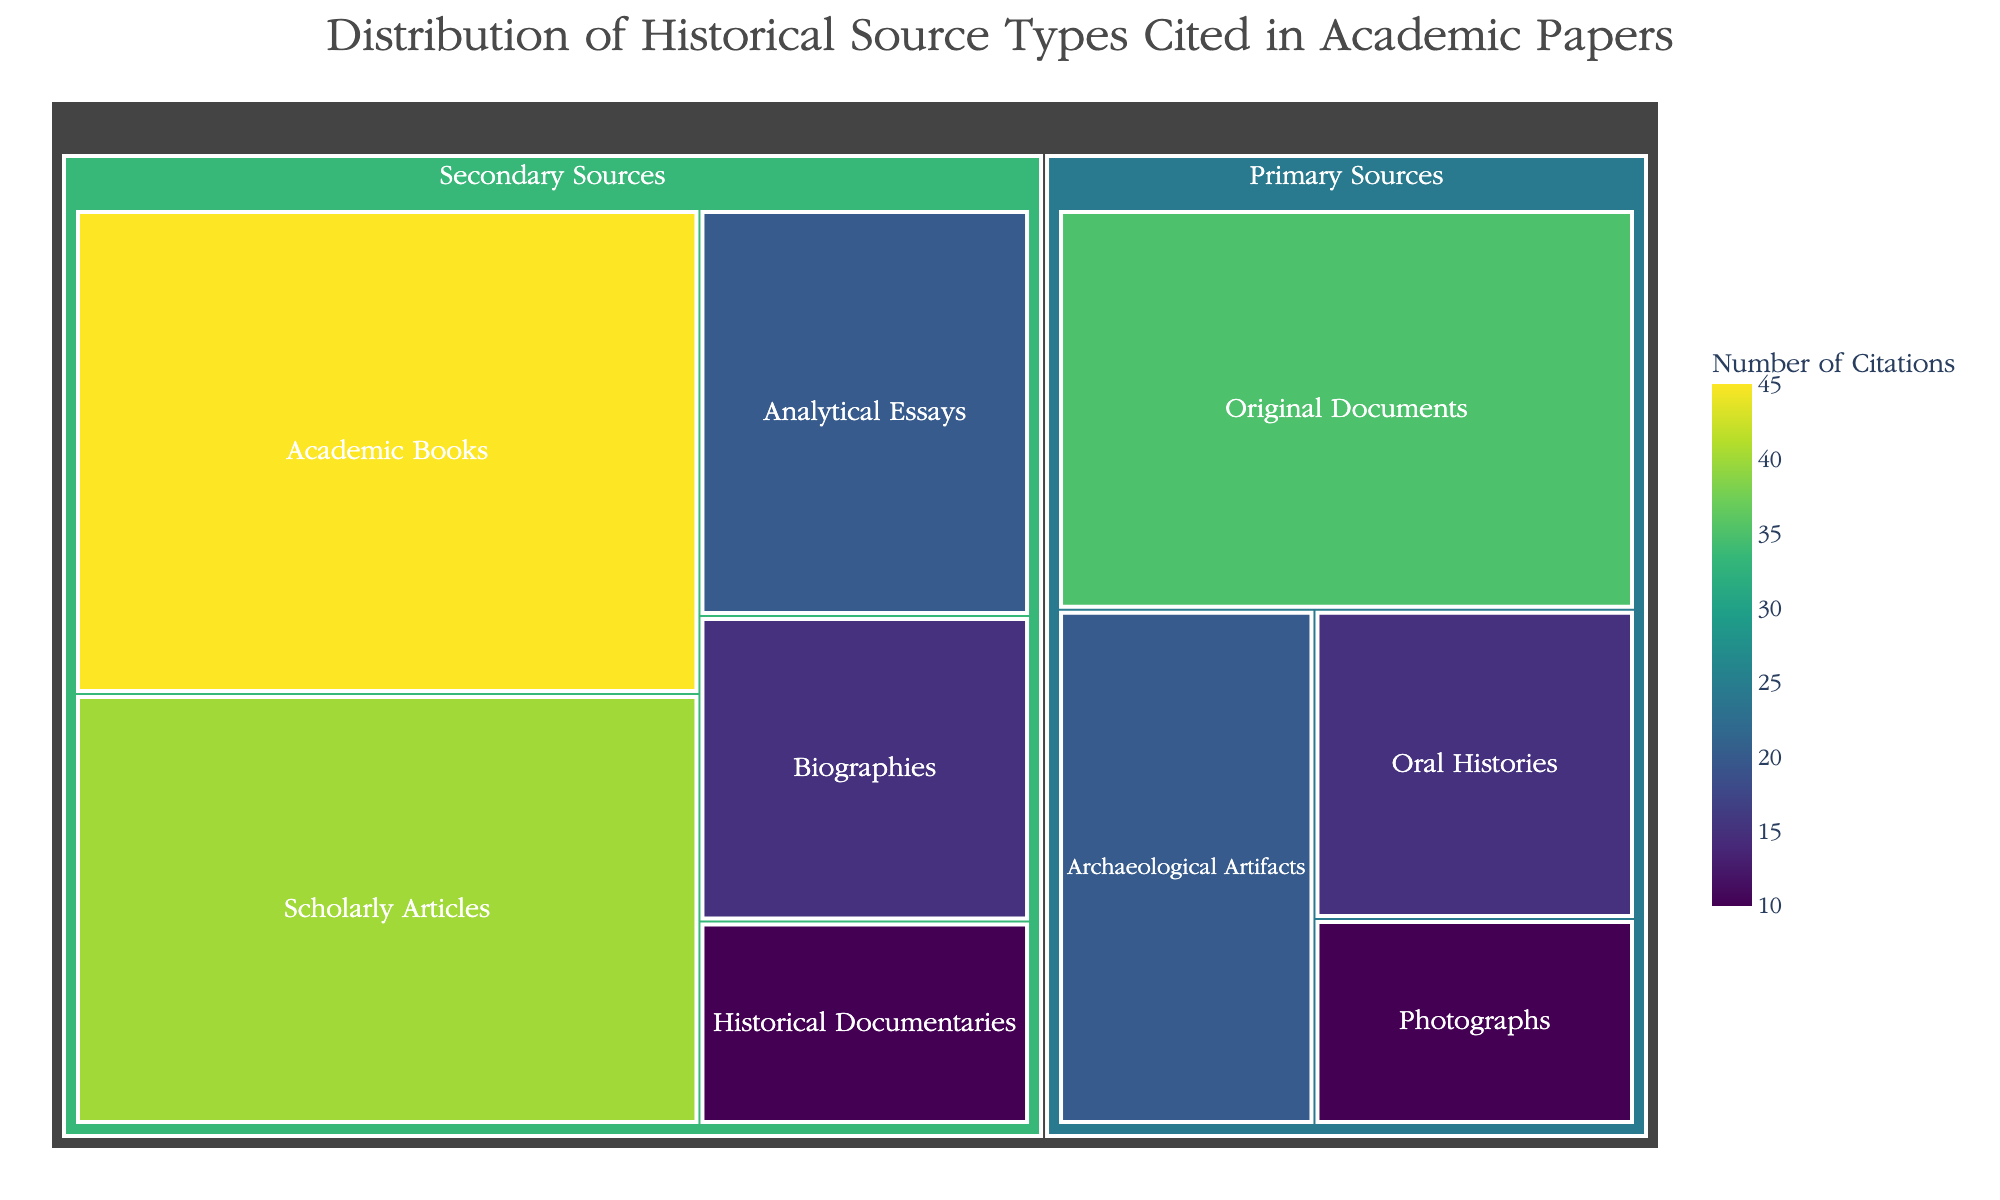What is the title of the figure? The title is usually clearly displayed at the top of the figure in a larger font. In this case, it's provided in the data.
Answer: Distribution of Historical Source Types Cited in Academic Papers Which subcategory of primary sources has the highest number of citations? To identify this, look for the box under "Primary Sources" with the largest size or highest value.
Answer: Original Documents How many subcategories of secondary sources are there? Count the distinct sections under the "Secondary Sources" category.
Answer: Five What is the total number of citations for secondary sources? Add up the values for all subcategories under "Secondary Sources": 45 + 40 + 15 + 20 + 10.
Answer: 130 Which has more citations: Scholarly Articles or Academic Books? Compare the values of these two subcategories directly.
Answer: Academic Books What is the difference in citations between Archaeological Artifacts and Analytical Essays? Subtract the value of "Archaeological Artifacts" from "Analytical Essays".
Answer: 0 Are oral histories cited more frequently than photographs? Compare the values of "Oral Histories" and "Photographs" to determine which is higher.
Answer: Yes What percentage of the total citations are from primary sources? First, calculate the total citations for primary sources: 20 + 35 + 15 + 10 = 80. Then, calculate the total citations overall: 80 (primary) + 130 (secondary) = 210. Finally, use the formula (citations from primary sources / total citations) * 100.
Answer: 38.1% Which primary source type has the least citations? Identify the smallest box within "Primary Sources."
Answer: Photographs What is the combined value of citations for Oral Histories and Biographies? Add the values of "Oral Histories" and "Biographies": 15 + 15.
Answer: 30 